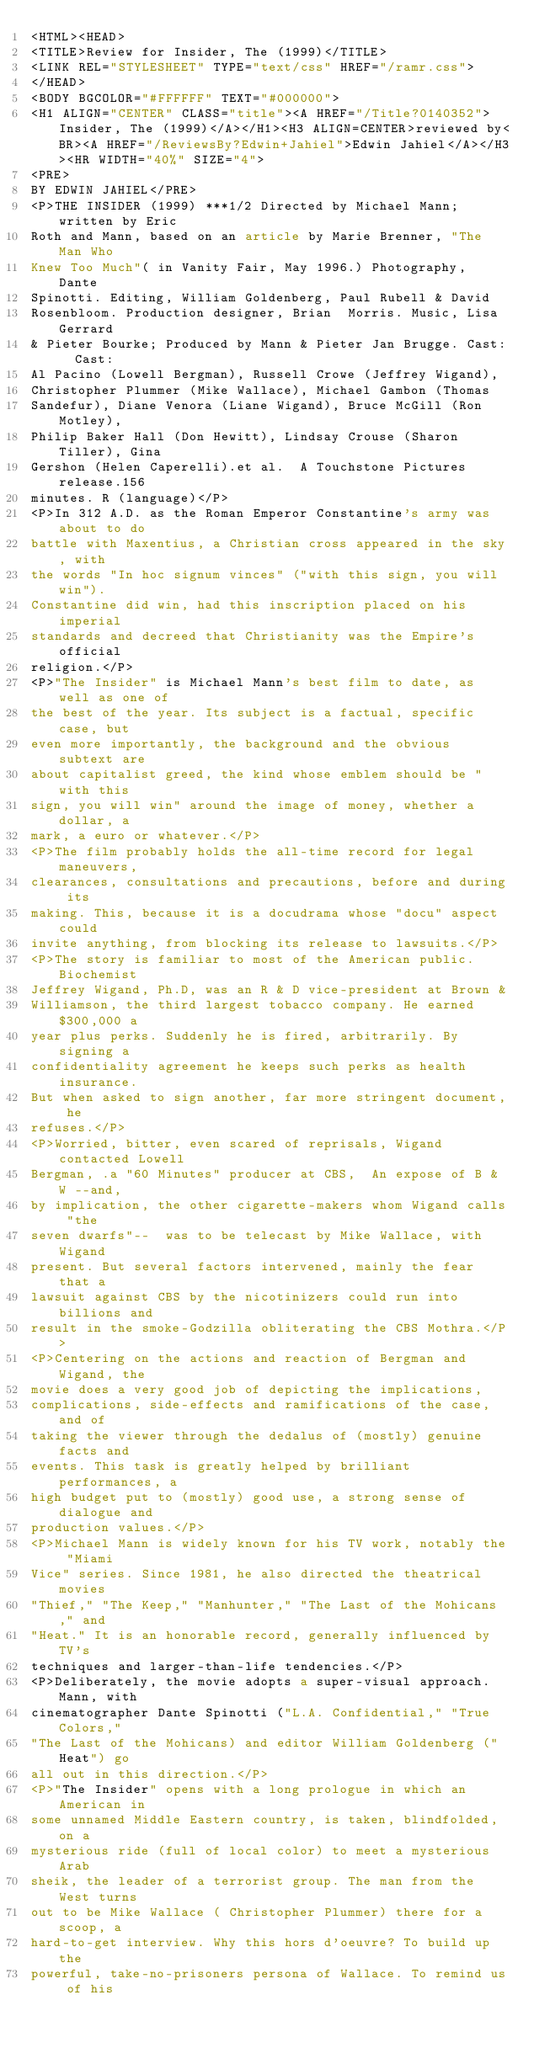Convert code to text. <code><loc_0><loc_0><loc_500><loc_500><_HTML_><HTML><HEAD>
<TITLE>Review for Insider, The (1999)</TITLE>
<LINK REL="STYLESHEET" TYPE="text/css" HREF="/ramr.css">
</HEAD>
<BODY BGCOLOR="#FFFFFF" TEXT="#000000">
<H1 ALIGN="CENTER" CLASS="title"><A HREF="/Title?0140352">Insider, The (1999)</A></H1><H3 ALIGN=CENTER>reviewed by<BR><A HREF="/ReviewsBy?Edwin+Jahiel">Edwin Jahiel</A></H3><HR WIDTH="40%" SIZE="4">
<PRE>
BY EDWIN JAHIEL</PRE>
<P>THE INSIDER (1999) ***1/2 Directed by Michael Mann; written by Eric 
Roth and Mann, based on an article by Marie Brenner, "The Man Who 
Knew Too Much"( in Vanity Fair, May 1996.) Photography, Dante 
Spinotti. Editing, William Goldenberg, Paul Rubell & David 
Rosenbloom. Production designer, Brian  Morris. Music, Lisa Gerrard 
& Pieter Bourke; Produced by Mann & Pieter Jan Brugge. Cast:  Cast: 
Al Pacino (Lowell Bergman), Russell Crowe (Jeffrey Wigand), 
Christopher Plummer (Mike Wallace), Michael Gambon (Thomas 
Sandefur), Diane Venora (Liane Wigand), Bruce McGill (Ron Motley), 
Philip Baker Hall (Don Hewitt), Lindsay Crouse (Sharon Tiller), Gina 
Gershon (Helen Caperelli).et al.  A Touchstone Pictures release.156 
minutes. R (language)</P>
<P>In 312 A.D. as the Roman Emperor Constantine's army was about to do 
battle with Maxentius, a Christian cross appeared in the sky, with 
the words "In hoc signum vinces" ("with this sign, you will win"). 
Constantine did win, had this inscription placed on his imperial 
standards and decreed that Christianity was the Empire's official 
religion.</P>
<P>"The Insider" is Michael Mann's best film to date, as well as one of 
the best of the year. Its subject is a factual, specific case, but 
even more importantly, the background and the obvious subtext are 
about capitalist greed, the kind whose emblem should be "with this 
sign, you will win" around the image of money, whether a dollar, a 
mark, a euro or whatever.</P>
<P>The film probably holds the all-time record for legal maneuvers, 
clearances, consultations and precautions, before and during its 
making. This, because it is a docudrama whose "docu" aspect could 
invite anything, from blocking its release to lawsuits.</P>
<P>The story is familiar to most of the American public. Biochemist 
Jeffrey Wigand, Ph.D, was an R & D vice-president at Brown & 
Williamson, the third largest tobacco company. He earned $300,000 a 
year plus perks. Suddenly he is fired, arbitrarily. By signing a 
confidentiality agreement he keeps such perks as health insurance. 
But when asked to sign another, far more stringent document, he 
refuses.</P>
<P>Worried, bitter, even scared of reprisals, Wigand contacted Lowell 
Bergman, .a "60 Minutes" producer at CBS,  An expose of B & W --and, 
by implication, the other cigarette-makers whom Wigand calls "the 
seven dwarfs"--  was to be telecast by Mike Wallace, with Wigand 
present. But several factors intervened, mainly the fear that a 
lawsuit against CBS by the nicotinizers could run into billions and 
result in the smoke-Godzilla obliterating the CBS Mothra.</P>
<P>Centering on the actions and reaction of Bergman and Wigand, the 
movie does a very good job of depicting the implications, 
complications, side-effects and ramifications of the case, and of 
taking the viewer through the dedalus of (mostly) genuine facts and 
events. This task is greatly helped by brilliant performances, a 
high budget put to (mostly) good use, a strong sense of dialogue and 
production values.</P>
<P>Michael Mann is widely known for his TV work, notably the "Miami 
Vice" series. Since 1981, he also directed the theatrical movies 
"Thief," "The Keep," "Manhunter," "The Last of the Mohicans," and 
"Heat." It is an honorable record, generally influenced by TV's 
techniques and larger-than-life tendencies.</P>
<P>Deliberately, the movie adopts a super-visual approach. Mann, with
cinematographer Dante Spinotti ("L.A. Confidential," "True Colors," 
"The Last of the Mohicans) and editor William Goldenberg ("Heat") go 
all out in this direction.</P>
<P>"The Insider" opens with a long prologue in which an American in 
some unnamed Middle Eastern country, is taken, blindfolded, on a 
mysterious ride (full of local color) to meet a mysterious Arab 
sheik, the leader of a terrorist group. The man from the West turns 
out to be Mike Wallace ( Christopher Plummer) there for a scoop, a 
hard-to-get interview. Why this hors d'oeuvre? To build up the 
powerful, take-no-prisoners persona of Wallace. To remind us of his </code> 